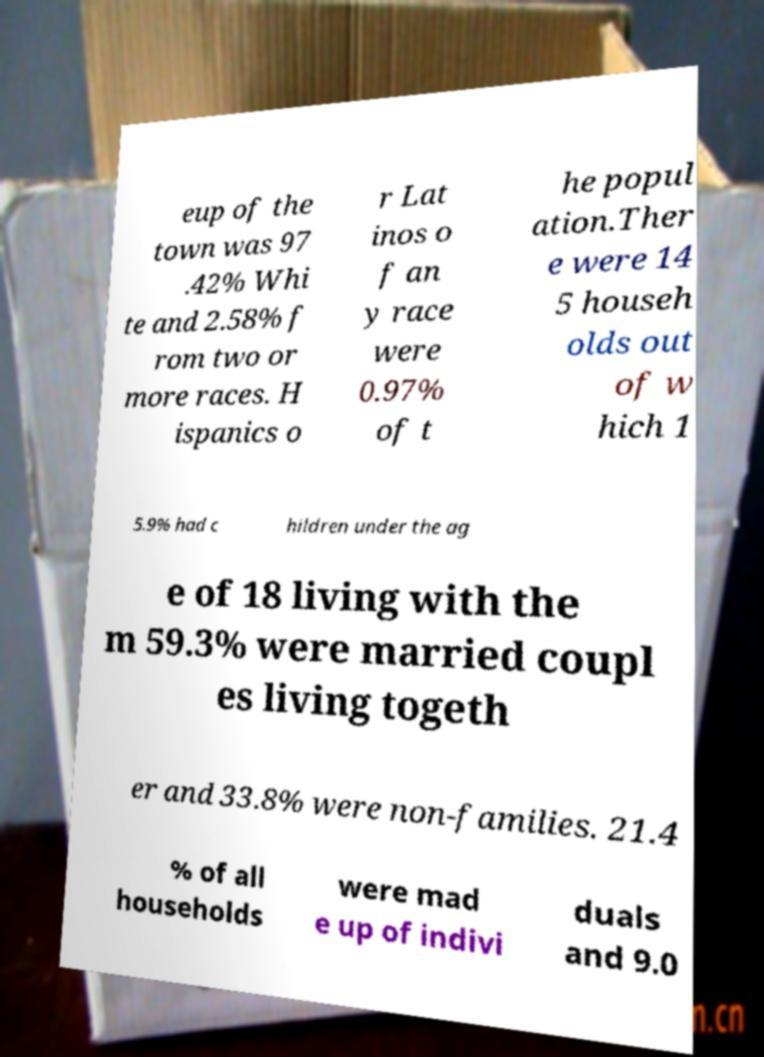Please read and relay the text visible in this image. What does it say? eup of the town was 97 .42% Whi te and 2.58% f rom two or more races. H ispanics o r Lat inos o f an y race were 0.97% of t he popul ation.Ther e were 14 5 househ olds out of w hich 1 5.9% had c hildren under the ag e of 18 living with the m 59.3% were married coupl es living togeth er and 33.8% were non-families. 21.4 % of all households were mad e up of indivi duals and 9.0 